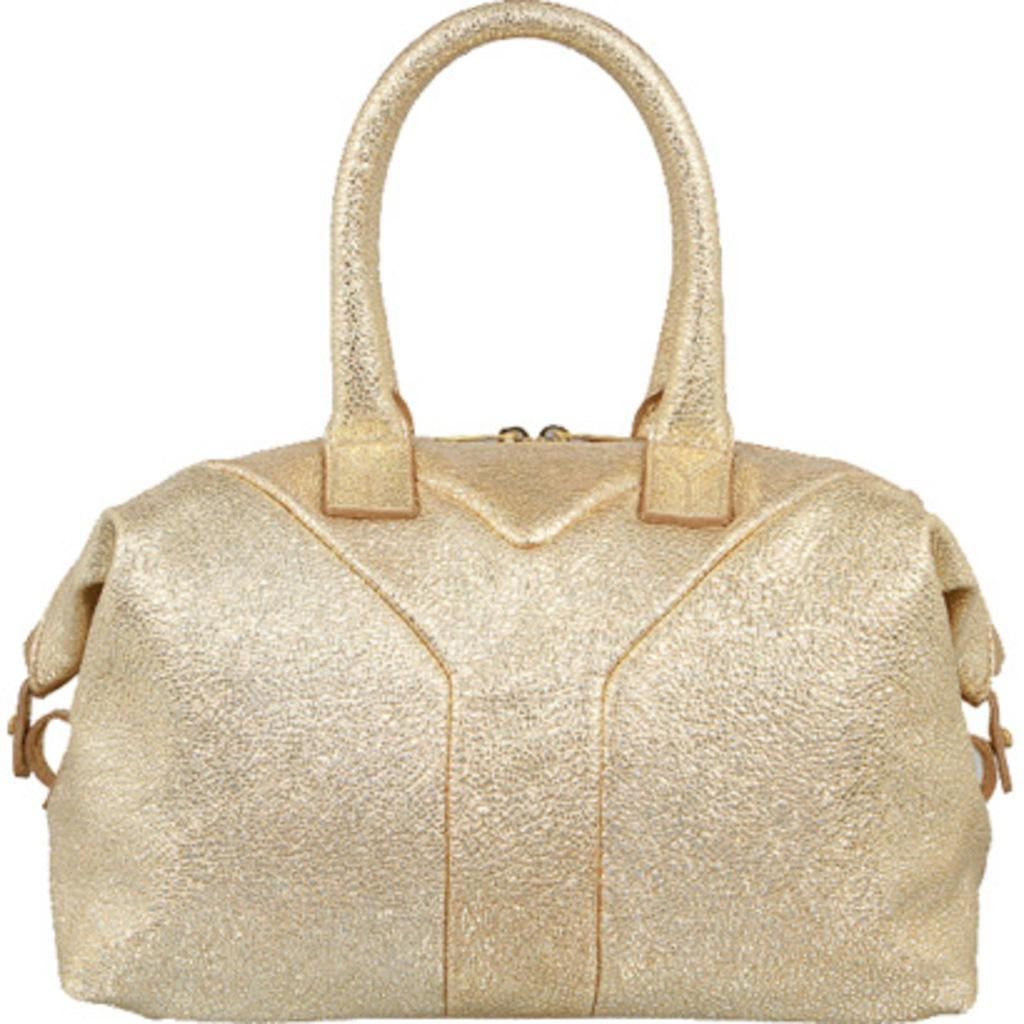What type of item is visible in the image? There is a handbag in the image. Can you describe the color of the handbag? The handbag has a golden color. What type of rice is being cooked in the image? There is no rice present in the image; it only features a handbag. What type of notebook is being used for work in the image? There is no notebook or work-related activity depicted in the image; it only features a handbag. 